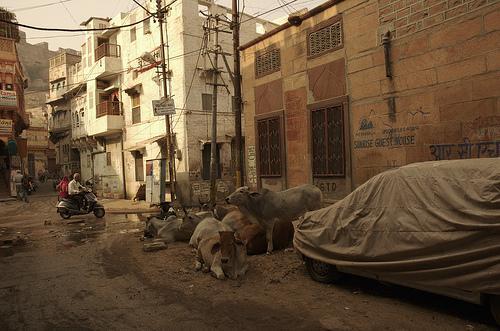How many people are on scooters?
Give a very brief answer. 1. 